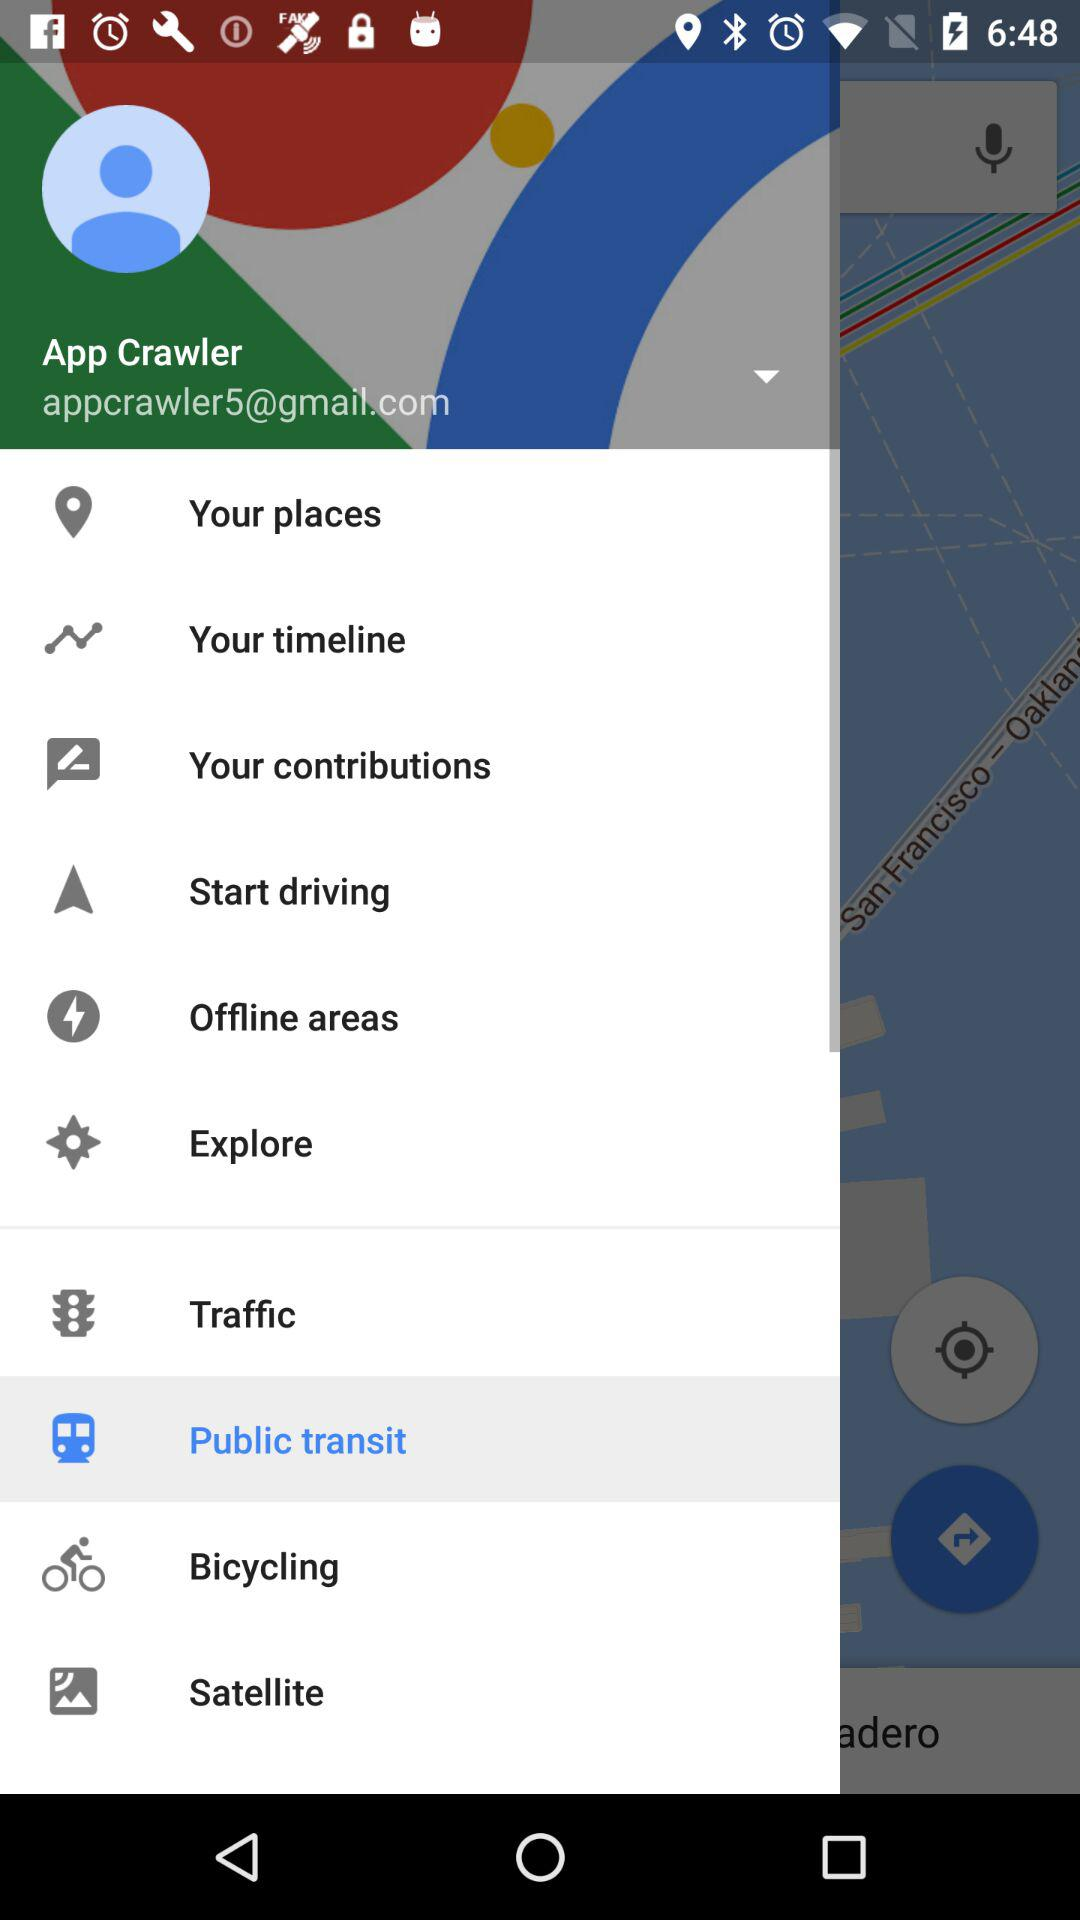Which item has been selected? The selected item is "Public transit". 